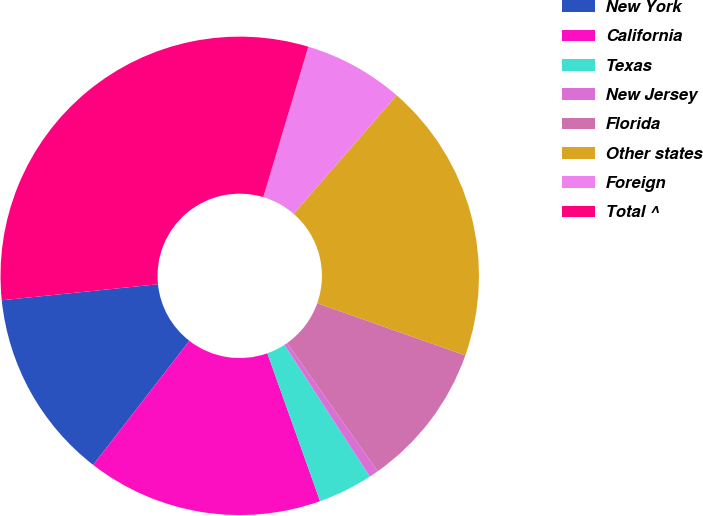Convert chart to OTSL. <chart><loc_0><loc_0><loc_500><loc_500><pie_chart><fcel>New York<fcel>California<fcel>Texas<fcel>New Jersey<fcel>Florida<fcel>Other states<fcel>Foreign<fcel>Total ^<nl><fcel>12.88%<fcel>15.95%<fcel>3.7%<fcel>0.63%<fcel>9.82%<fcel>19.01%<fcel>6.76%<fcel>31.26%<nl></chart> 